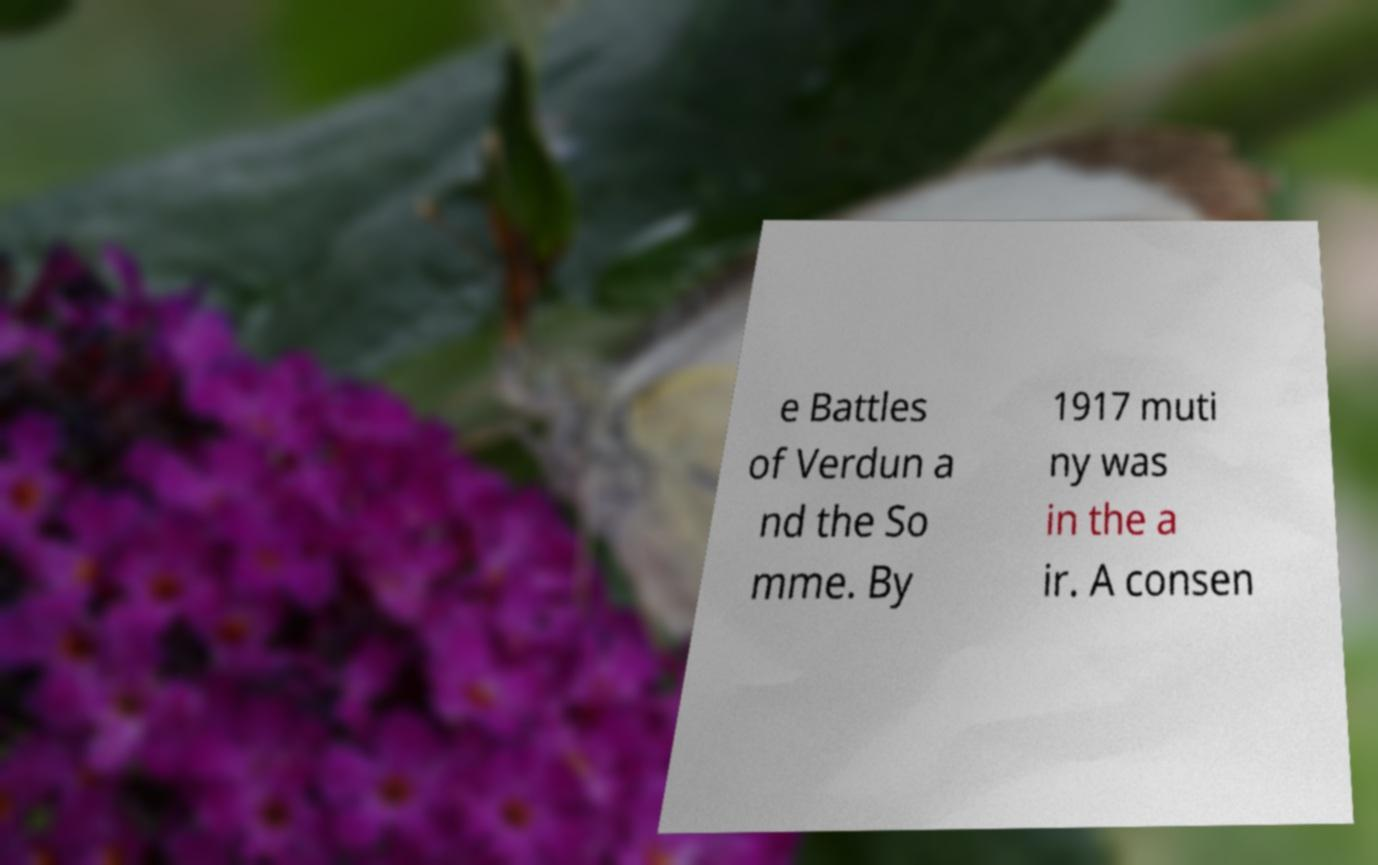Please identify and transcribe the text found in this image. e Battles of Verdun a nd the So mme. By 1917 muti ny was in the a ir. A consen 